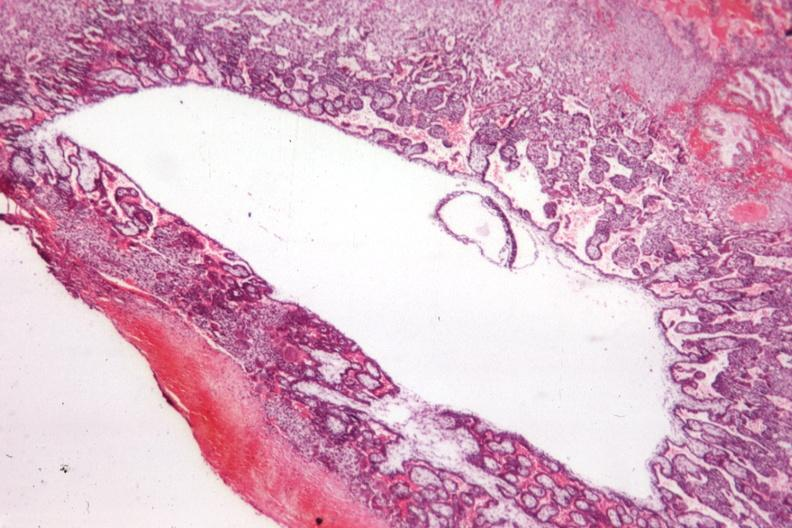s female reproductive present?
Answer the question using a single word or phrase. Yes 